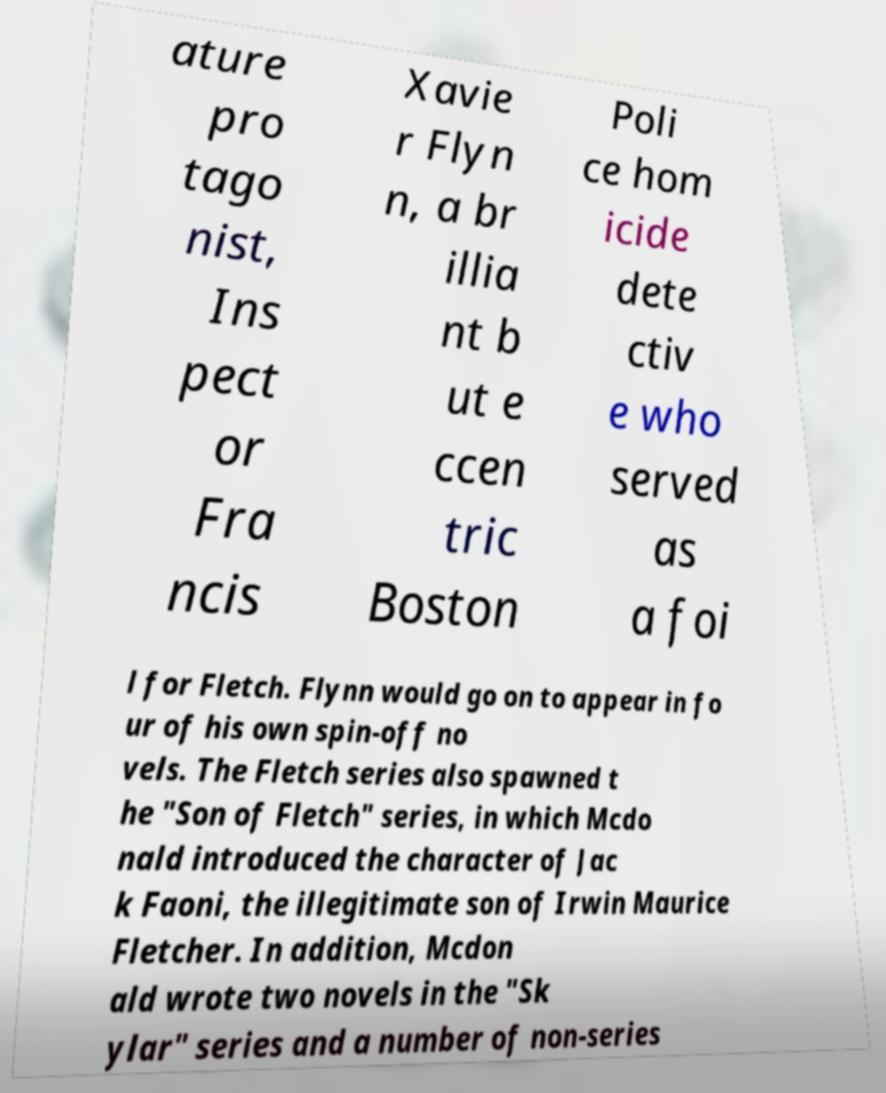Can you accurately transcribe the text from the provided image for me? ature pro tago nist, Ins pect or Fra ncis Xavie r Flyn n, a br illia nt b ut e ccen tric Boston Poli ce hom icide dete ctiv e who served as a foi l for Fletch. Flynn would go on to appear in fo ur of his own spin-off no vels. The Fletch series also spawned t he "Son of Fletch" series, in which Mcdo nald introduced the character of Jac k Faoni, the illegitimate son of Irwin Maurice Fletcher. In addition, Mcdon ald wrote two novels in the "Sk ylar" series and a number of non-series 